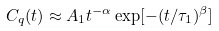<formula> <loc_0><loc_0><loc_500><loc_500>C _ { q } ( t ) \approx A _ { 1 } t ^ { - \alpha } \exp [ - ( t / \tau _ { 1 } ) ^ { \beta } ]</formula> 